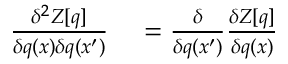<formula> <loc_0><loc_0><loc_500><loc_500>\begin{array} { r l } { \frac { \delta ^ { 2 } Z [ q ] } { \delta q ( x ) \delta q ( x ^ { \prime } ) } } & = \frac { \delta } { \delta q ( x ^ { \prime } ) } \frac { \delta Z [ q ] } { \delta q ( x ) } } \end{array}</formula> 